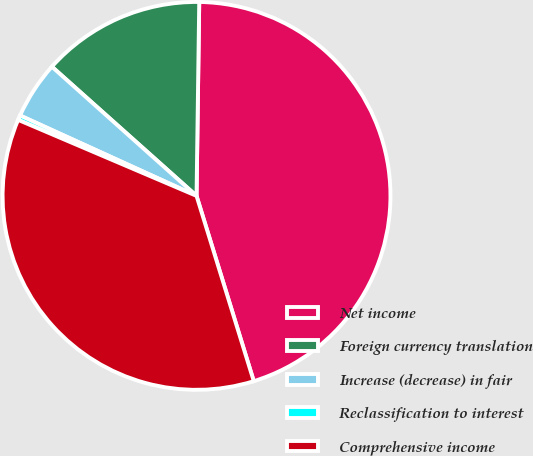Convert chart. <chart><loc_0><loc_0><loc_500><loc_500><pie_chart><fcel>Net income<fcel>Foreign currency translation<fcel>Increase (decrease) in fair<fcel>Reclassification to interest<fcel>Comprehensive income<nl><fcel>45.01%<fcel>13.62%<fcel>4.8%<fcel>0.39%<fcel>36.18%<nl></chart> 